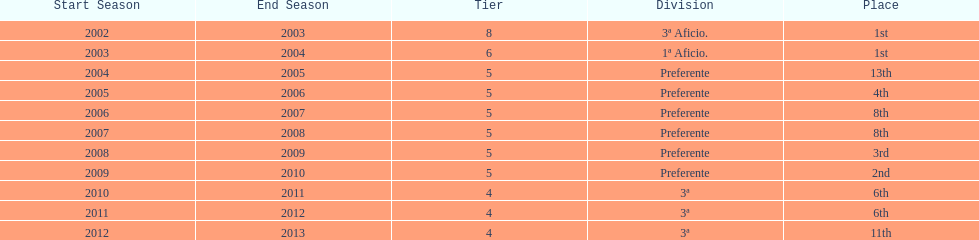What place was 1a aficio and 3a aficio? 1st. 